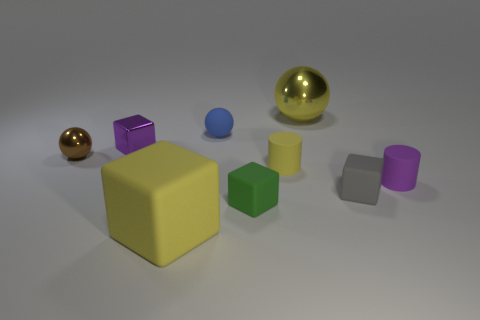What shape is the yellow metallic object that is to the right of the brown shiny object?
Provide a succinct answer. Sphere. The large yellow thing that is right of the small rubber block in front of the rubber block that is on the right side of the yellow ball is made of what material?
Provide a short and direct response. Metal. What number of other objects are the same size as the brown metallic sphere?
Your response must be concise. 6. There is a yellow thing that is the same shape as the small blue thing; what is its material?
Keep it short and to the point. Metal. What is the color of the big metal object?
Provide a succinct answer. Yellow. There is a tiny matte cylinder on the left side of the shiny ball that is on the right side of the large matte cube; what color is it?
Give a very brief answer. Yellow. Is the color of the large sphere the same as the large thing that is in front of the tiny blue rubber object?
Make the answer very short. Yes. There is a small ball that is on the right side of the cube to the left of the large yellow block; how many tiny metal balls are on the right side of it?
Your answer should be very brief. 0. Are there any large yellow objects in front of the big yellow sphere?
Your response must be concise. Yes. Are there any other things that are the same color as the big metallic sphere?
Your answer should be very brief. Yes. 